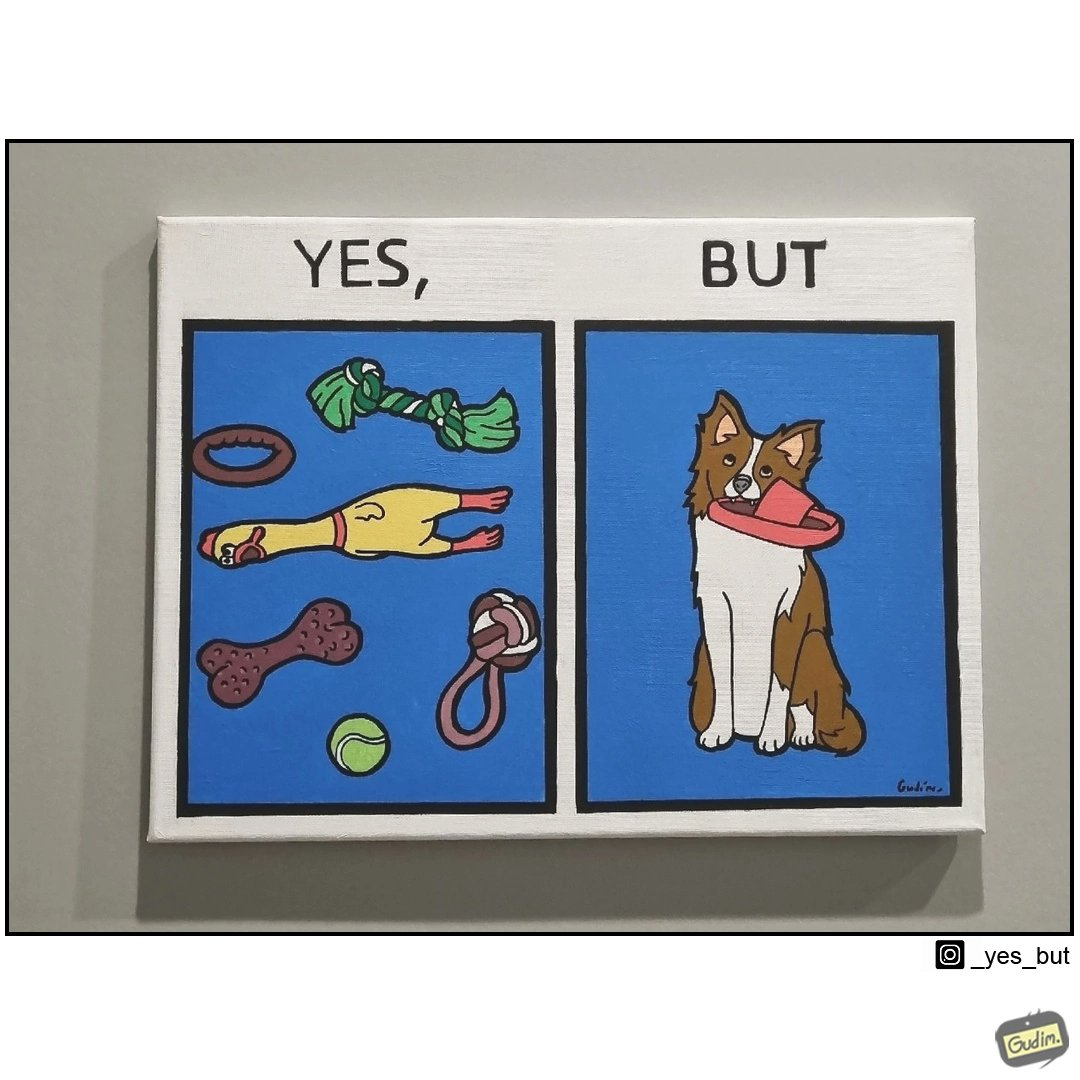Describe the contrast between the left and right parts of this image. In the left part of the image: a bunch of toys In the right part of the image: a dog holding a slipper 